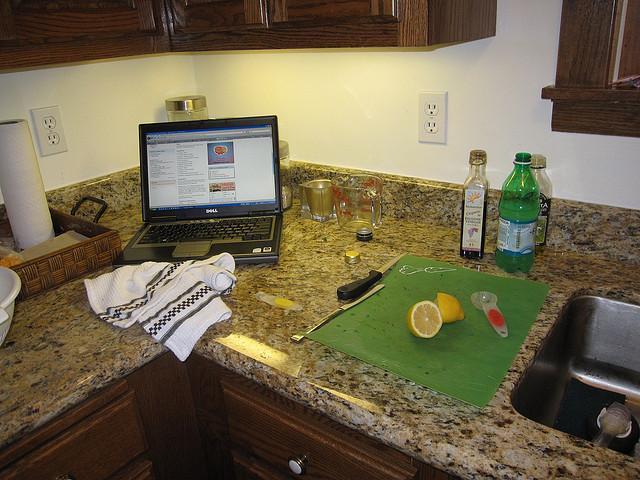How many bottles are there?
Give a very brief answer. 2. How many airplanes are in the photo?
Give a very brief answer. 0. 